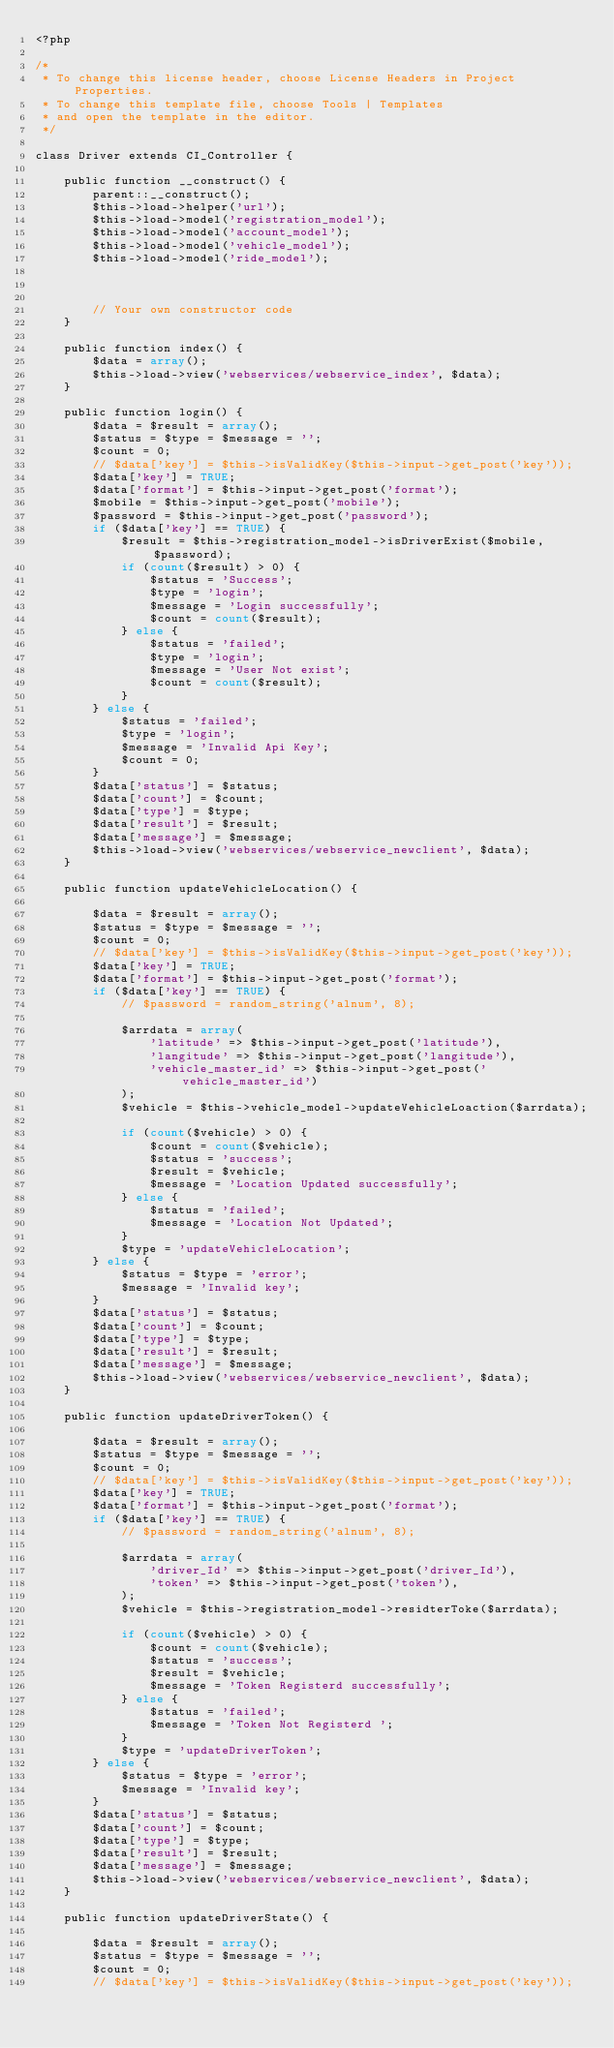<code> <loc_0><loc_0><loc_500><loc_500><_PHP_><?php

/*
 * To change this license header, choose License Headers in Project Properties.
 * To change this template file, choose Tools | Templates
 * and open the template in the editor.
 */

class Driver extends CI_Controller {

    public function __construct() {
        parent::__construct();
        $this->load->helper('url');
        $this->load->model('registration_model');
        $this->load->model('account_model');
        $this->load->model('vehicle_model');
        $this->load->model('ride_model');
        
        

        // Your own constructor code
    }

    public function index() {
        $data = array();
        $this->load->view('webservices/webservice_index', $data);
    }

    public function login() {
        $data = $result = array();
        $status = $type = $message = '';
        $count = 0;
        // $data['key'] = $this->isValidKey($this->input->get_post('key'));
        $data['key'] = TRUE;
        $data['format'] = $this->input->get_post('format');
        $mobile = $this->input->get_post('mobile');
        $password = $this->input->get_post('password');
        if ($data['key'] == TRUE) {
            $result = $this->registration_model->isDriverExist($mobile, $password);
            if (count($result) > 0) {
                $status = 'Success';
                $type = 'login';
                $message = 'Login successfully';
                $count = count($result);
            } else {
                $status = 'failed';
                $type = 'login';
                $message = 'User Not exist';
                $count = count($result);
            }
        } else {
            $status = 'failed';
            $type = 'login';
            $message = 'Invalid Api Key';
            $count = 0;
        }
        $data['status'] = $status;
        $data['count'] = $count;
        $data['type'] = $type;
        $data['result'] = $result;
        $data['message'] = $message;
        $this->load->view('webservices/webservice_newclient', $data);
    }

    public function updateVehicleLocation() {

        $data = $result = array();
        $status = $type = $message = '';
        $count = 0;
        // $data['key'] = $this->isValidKey($this->input->get_post('key'));
        $data['key'] = TRUE;
        $data['format'] = $this->input->get_post('format');
        if ($data['key'] == TRUE) {
            // $password = random_string('alnum', 8);

            $arrdata = array(
                'latitude' => $this->input->get_post('latitude'),
                'langitude' => $this->input->get_post('langitude'),
                'vehicle_master_id' => $this->input->get_post('vehicle_master_id')
            );
            $vehicle = $this->vehicle_model->updateVehicleLoaction($arrdata);

            if (count($vehicle) > 0) {
                $count = count($vehicle);
                $status = 'success';
                $result = $vehicle;
                $message = 'Location Updated successfully';
            } else {
                $status = 'failed';
                $message = 'Location Not Updated';
            }
            $type = 'updateVehicleLocation';
        } else {
            $status = $type = 'error';
            $message = 'Invalid key';
        }
        $data['status'] = $status;
        $data['count'] = $count;
        $data['type'] = $type;
        $data['result'] = $result;
        $data['message'] = $message;
        $this->load->view('webservices/webservice_newclient', $data);
    }

    public function updateDriverToken() {

        $data = $result = array();
        $status = $type = $message = '';
        $count = 0;
        // $data['key'] = $this->isValidKey($this->input->get_post('key'));
        $data['key'] = TRUE;
        $data['format'] = $this->input->get_post('format');
        if ($data['key'] == TRUE) {
            // $password = random_string('alnum', 8);

            $arrdata = array(
                'driver_Id' => $this->input->get_post('driver_Id'),
                'token' => $this->input->get_post('token'),
            );
            $vehicle = $this->registration_model->residterToke($arrdata);

            if (count($vehicle) > 0) {
                $count = count($vehicle);
                $status = 'success';
                $result = $vehicle;
                $message = 'Token Registerd successfully';
            } else {
                $status = 'failed';
                $message = 'Token Not Registerd ';
            }
            $type = 'updateDriverToken';
        } else {
            $status = $type = 'error';
            $message = 'Invalid key';
        }
        $data['status'] = $status;
        $data['count'] = $count;
        $data['type'] = $type;
        $data['result'] = $result;
        $data['message'] = $message;
        $this->load->view('webservices/webservice_newclient', $data);
    }
    
    public function updateDriverState() {

        $data = $result = array();
        $status = $type = $message = '';
        $count = 0;
        // $data['key'] = $this->isValidKey($this->input->get_post('key'));</code> 